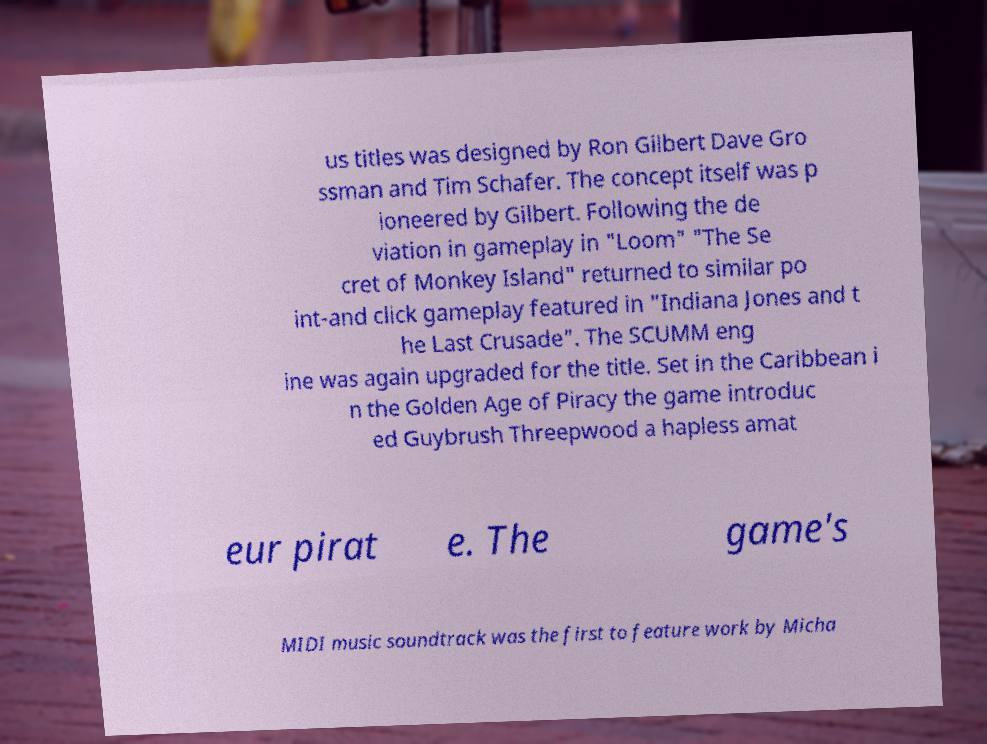Please identify and transcribe the text found in this image. us titles was designed by Ron Gilbert Dave Gro ssman and Tim Schafer. The concept itself was p ioneered by Gilbert. Following the de viation in gameplay in "Loom" "The Se cret of Monkey Island" returned to similar po int-and click gameplay featured in "Indiana Jones and t he Last Crusade". The SCUMM eng ine was again upgraded for the title. Set in the Caribbean i n the Golden Age of Piracy the game introduc ed Guybrush Threepwood a hapless amat eur pirat e. The game's MIDI music soundtrack was the first to feature work by Micha 